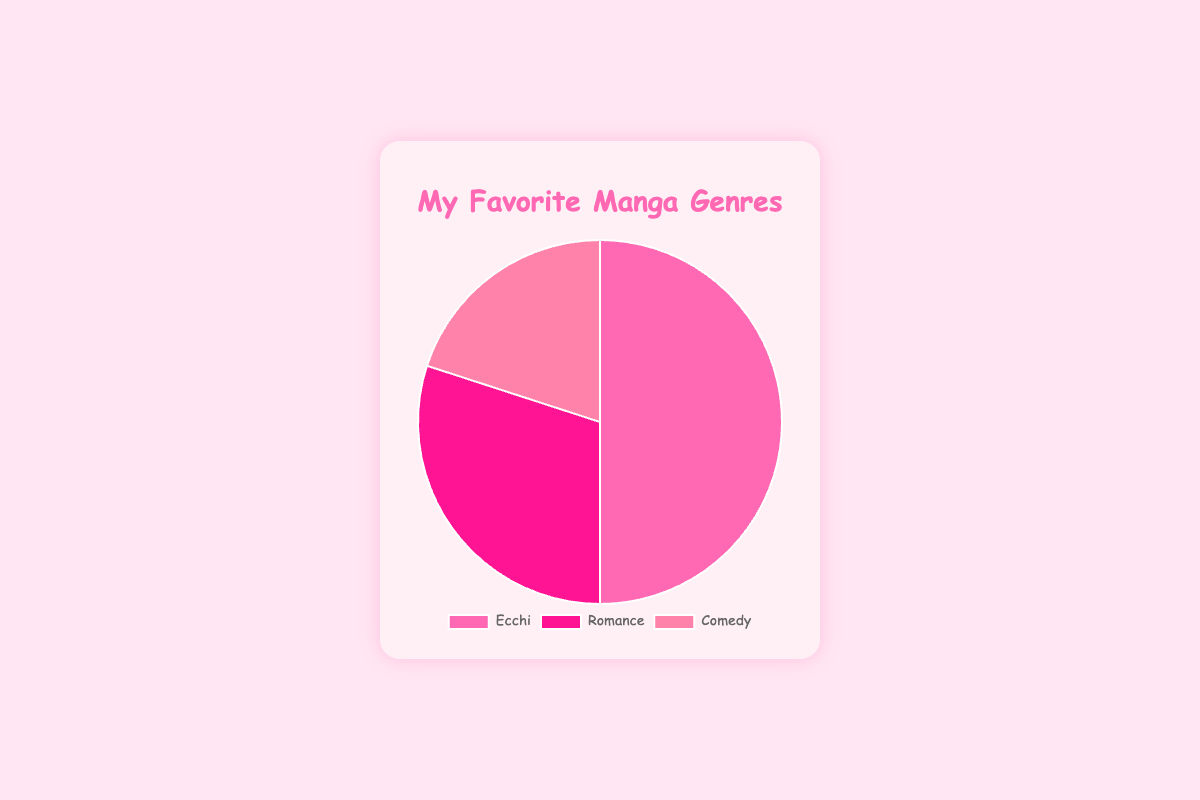What percentage of the total favorite manga genres does Ecchi contribute? The pie chart shows the percentage distribution of favorite manga genres. By looking at the segment labeled "Ecchi," you can see it contributes 50% of the total.
Answer: 50% How much more popular is Ecchi than Comedy? Ecchi is represented as 50%, and Comedy is 20%. The difference in popularity between Ecchi and Comedy is 50% - 20% = 30%.
Answer: 30% Which genre has the smallest share in the pie chart? By examining the size of each segment, Comedy has the smallest share with only 20%.
Answer: Comedy What is the combined percentage of Romance and Comedy genres? By adding the percentages for Romance (30%) and Comedy (20%), the combined percentage is 30% + 20% = 50%.
Answer: 50% What part does Romance play in the favorite manga genres, visually? The Romance segment is displayed in a distinct color occupying 30% of the pie chart’s area.
Answer: 30% If we wanted to split the chart into two equally sized portions, could we do that using the given genres? None of the two-genre combinations sum up to 50%. Ecchi alone is 50%, but combining it with any other genre exceeds 50%. Therefore, it's impossible to split the chart into two exactly equal halves using the given genres.
Answer: No Is the share of Ecchi equal to the sum of Romance and Comedy? Adding the percentages of Romance (30%) and Comedy (20%) gives 30% + 20% = 50%. This is equal to the percentage of Ecchi, which is 50%.
Answer: Yes How does the popularity of Romance compare to Comedy? Romance's percentage (30%) is greater than Comedy's (20%) by a difference of 10%.
Answer: Romance is 10% more popular What visual feature indicates the most popular genre? The largest segment of the pie chart, both in area and percentage, represents the most popular genre, which is Ecchi with 50%.
Answer: Largest segment Which genres together make up 80% of the favorite manga genres? Adding the percentages of Ecchi (50%) and Romance (30%) gives 50% + 30% = 80%. Therefore, Ecchi and Romance together make up 80%.
Answer: Ecchi and Romance 